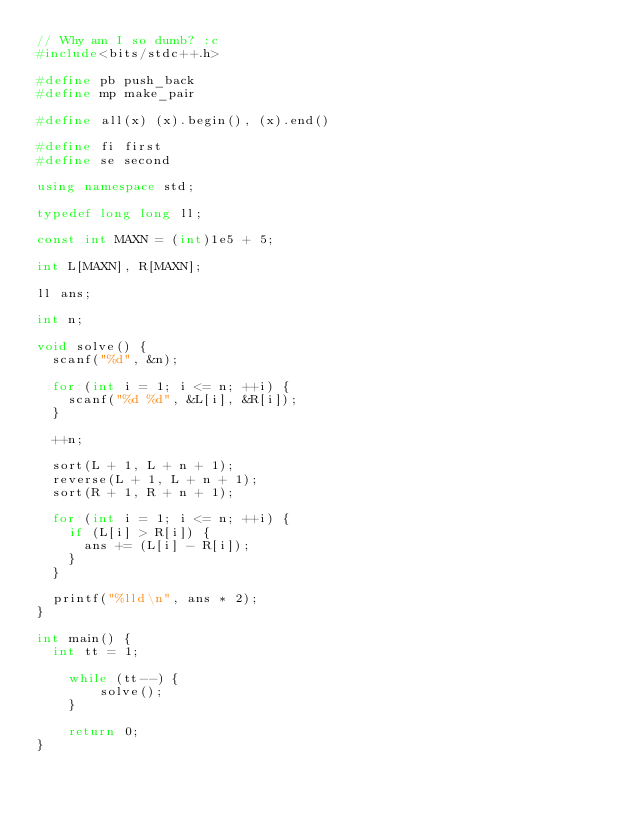<code> <loc_0><loc_0><loc_500><loc_500><_C++_>// Why am I so dumb? :c
#include<bits/stdc++.h>

#define pb push_back
#define mp make_pair

#define all(x) (x).begin(), (x).end()

#define fi first
#define se second

using namespace std;

typedef long long ll;

const int MAXN = (int)1e5 + 5;

int L[MAXN], R[MAXN];

ll ans;

int n;

void solve() {
	scanf("%d", &n);

	for (int i = 1; i <= n; ++i) {
		scanf("%d %d", &L[i], &R[i]);
	}

	++n;

	sort(L + 1, L + n + 1);
	reverse(L + 1, L + n + 1);
	sort(R + 1, R + n + 1);

	for (int i = 1; i <= n; ++i) {
		if (L[i] > R[i]) {
			ans += (L[i] - R[i]);
		}
	}

	printf("%lld\n", ans * 2);	
}

int main() {
	int tt = 1;

    while (tt--) {
        solve();
    }

    return 0;
}</code> 